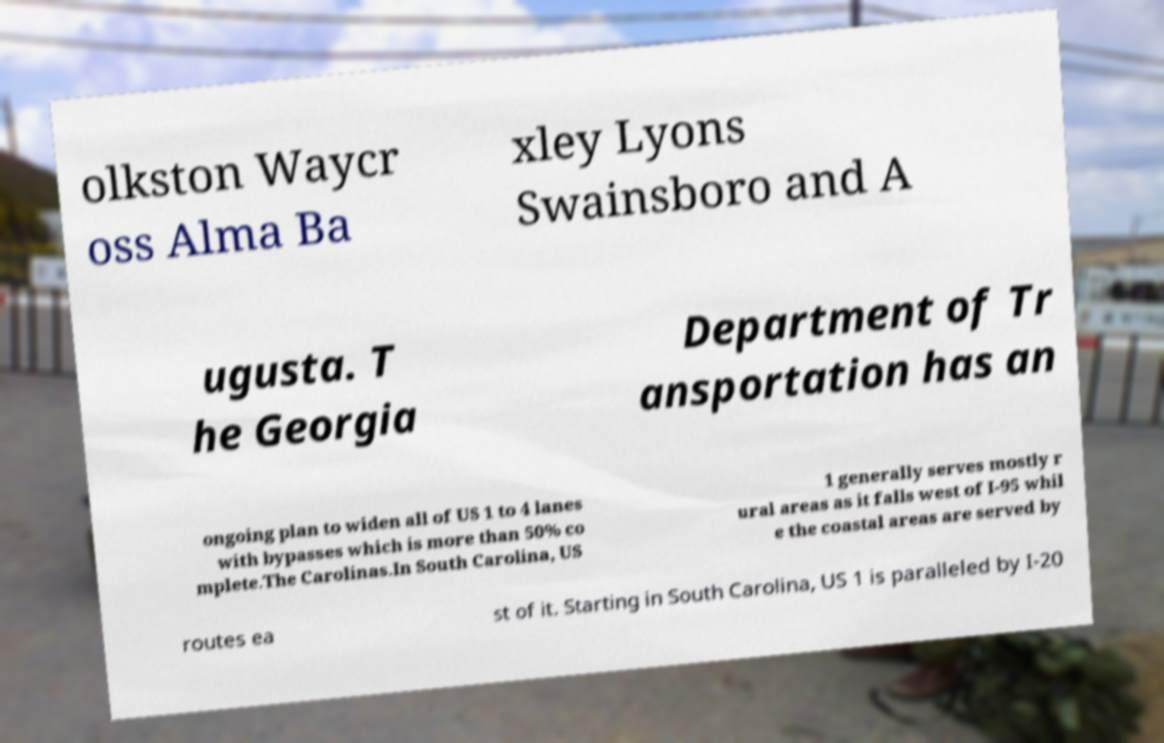What messages or text are displayed in this image? I need them in a readable, typed format. olkston Waycr oss Alma Ba xley Lyons Swainsboro and A ugusta. T he Georgia Department of Tr ansportation has an ongoing plan to widen all of US 1 to 4 lanes with bypasses which is more than 50% co mplete.The Carolinas.In South Carolina, US 1 generally serves mostly r ural areas as it falls west of I-95 whil e the coastal areas are served by routes ea st of it. Starting in South Carolina, US 1 is paralleled by I-20 